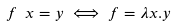Convert formula to latex. <formula><loc_0><loc_0><loc_500><loc_500>f \ x = y \iff f = \lambda x . y</formula> 